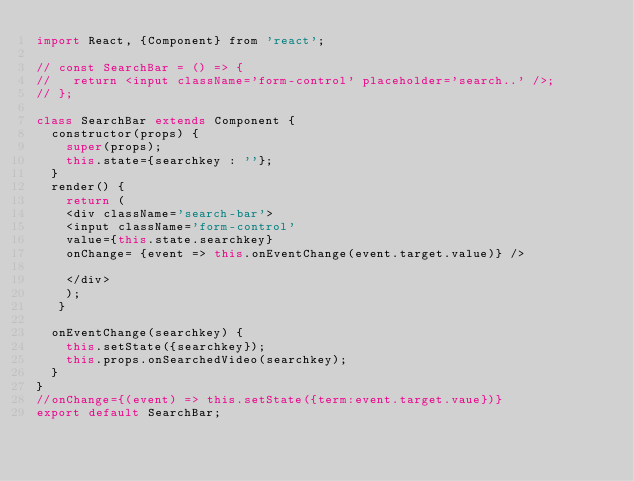Convert code to text. <code><loc_0><loc_0><loc_500><loc_500><_JavaScript_>import React, {Component} from 'react';

// const SearchBar = () => {
//   return <input className='form-control' placeholder='search..' />;
// };

class SearchBar extends Component {
  constructor(props) {
    super(props);
    this.state={searchkey : ''};
  }
  render() {
    return (
    <div className='search-bar'>
    <input className='form-control'
    value={this.state.searchkey}
    onChange= {event => this.onEventChange(event.target.value)} />

    </div>
    );
   }

  onEventChange(searchkey) {
    this.setState({searchkey});
    this.props.onSearchedVideo(searchkey);
  }
}
//onChange={(event) => this.setState({term:event.target.vaue})}
export default SearchBar;
</code> 